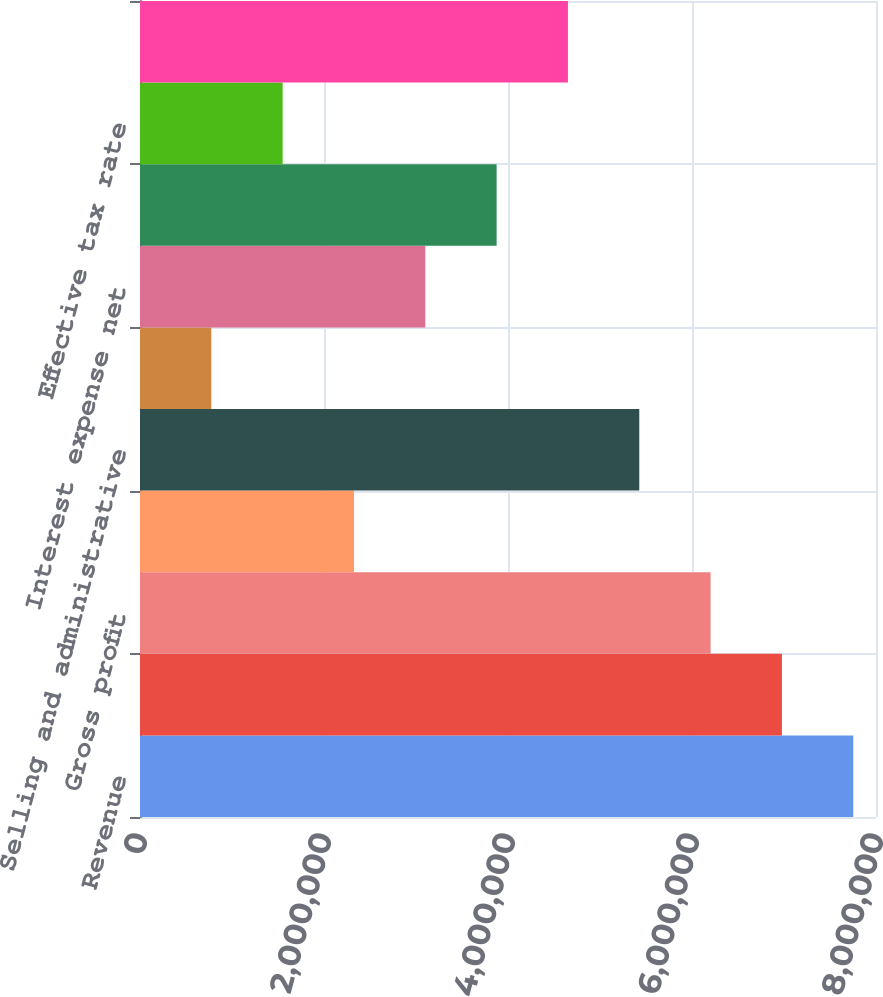Convert chart. <chart><loc_0><loc_0><loc_500><loc_500><bar_chart><fcel>Revenue<fcel>Cost of goods and services<fcel>Gross profit<fcel>Gross profit margin<fcel>Selling and administrative<fcel>Selling and administrative as<fcel>Interest expense net<fcel>Provision for income taxes<fcel>Effective tax rate<fcel>Earnings from continuing<nl><fcel>7.75273e+06<fcel>6.97746e+06<fcel>6.20218e+06<fcel>2.32582e+06<fcel>5.42691e+06<fcel>775277<fcel>3.10109e+06<fcel>3.87637e+06<fcel>1.55055e+06<fcel>4.65164e+06<nl></chart> 